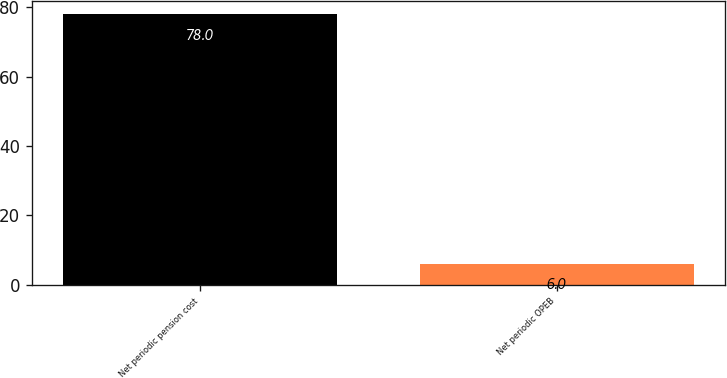<chart> <loc_0><loc_0><loc_500><loc_500><bar_chart><fcel>Net periodic pension cost<fcel>Net periodic OPEB<nl><fcel>78<fcel>6<nl></chart> 